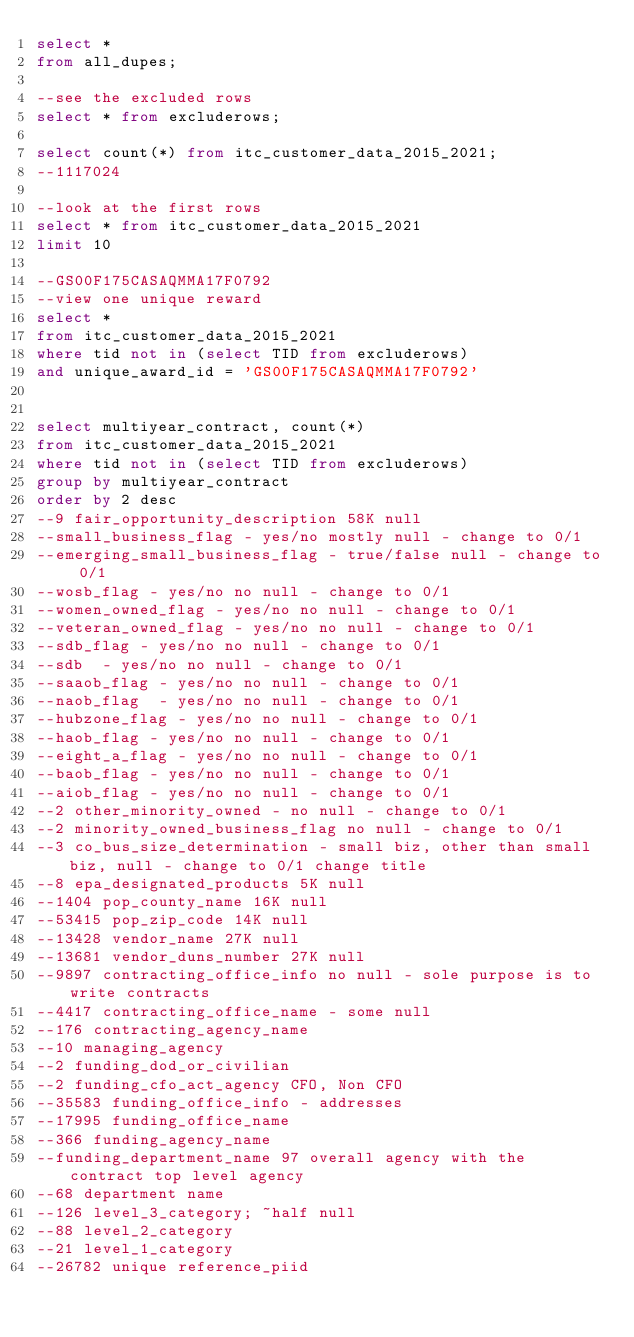<code> <loc_0><loc_0><loc_500><loc_500><_SQL_>select *
from all_dupes;

--see the excluded rows
select * from excluderows;

select count(*) from itc_customer_data_2015_2021;
--1117024

--look at the first rows
select * from itc_customer_data_2015_2021
limit 10

--GS00F175CASAQMMA17F0792
--view one unique reward
select *
from itc_customer_data_2015_2021
where tid not in (select TID from excluderows)
and unique_award_id = 'GS00F175CASAQMMA17F0792'


select multiyear_contract, count(*)
from itc_customer_data_2015_2021
where tid not in (select TID from excluderows)
group by multiyear_contract
order by 2 desc
--9 fair_opportunity_description 58K null
--small_business_flag - yes/no mostly null - change to 0/1
--emerging_small_business_flag - true/false null - change to 0/1
--wosb_flag - yes/no no null - change to 0/1
--women_owned_flag - yes/no no null - change to 0/1
--veteran_owned_flag - yes/no no null - change to 0/1
--sdb_flag - yes/no no null - change to 0/1
--sdb  - yes/no no null - change to 0/1
--saaob_flag - yes/no no null - change to 0/1
--naob_flag  - yes/no no null - change to 0/1
--hubzone_flag - yes/no no null - change to 0/1
--haob_flag - yes/no no null - change to 0/1
--eight_a_flag - yes/no no null - change to 0/1
--baob_flag - yes/no no null - change to 0/1
--aiob_flag - yes/no no null - change to 0/1
--2 other_minority_owned - no null - change to 0/1
--2 minority_owned_business_flag no null - change to 0/1
--3 co_bus_size_determination - small biz, other than small biz, null - change to 0/1 change title
--8 epa_designated_products 5K null
--1404 pop_county_name 16K null
--53415 pop_zip_code 14K null
--13428 vendor_name 27K null
--13681 vendor_duns_number 27K null
--9897 contracting_office_info no null - sole purpose is to write contracts
--4417 contracting_office_name - some null
--176 contracting_agency_name
--10 managing_agency
--2 funding_dod_or_civilian
--2 funding_cfo_act_agency CFO, Non CFO
--35583 funding_office_info - addresses
--17995 funding_office_name
--366 funding_agency_name
--funding_department_name 97 overall agency with the contract top level agency
--68 department name
--126 level_3_category; ~half null
--88 level_2_category
--21 level_1_category
--26782 unique reference_piid</code> 